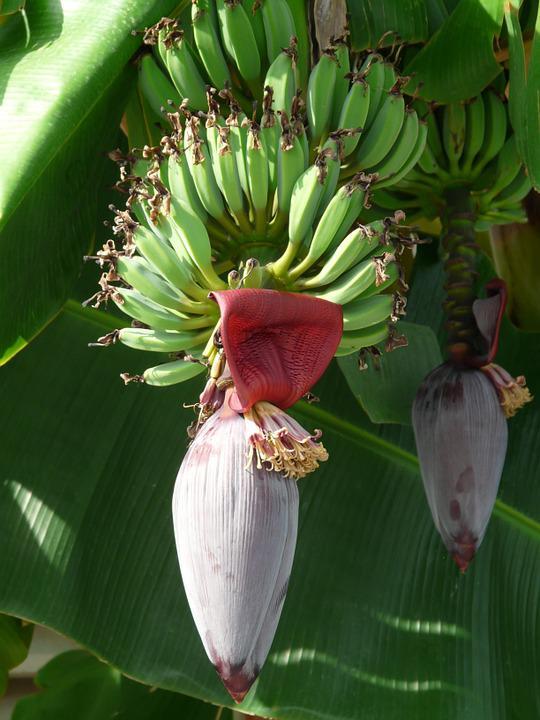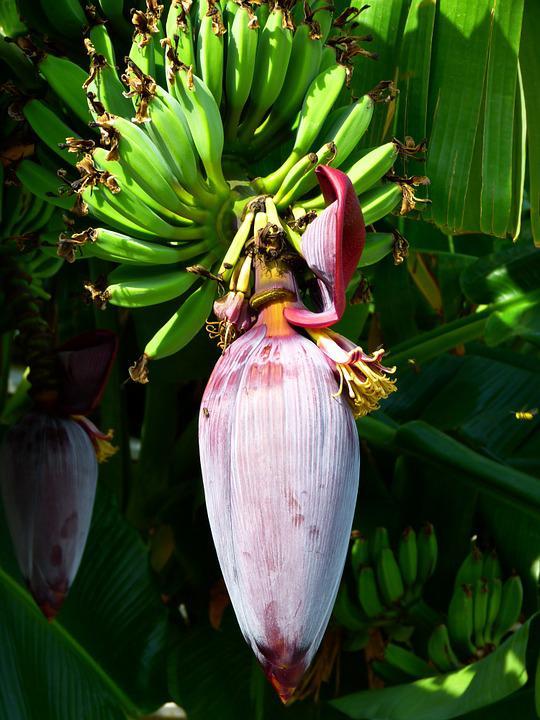The first image is the image on the left, the second image is the image on the right. For the images displayed, is the sentence "At the bottom of the bananas the flower has at least four petals open." factually correct? Answer yes or no. No. The first image is the image on the left, the second image is the image on the right. Evaluate the accuracy of this statement regarding the images: "There is exactly one flower petal in the left image.". Is it true? Answer yes or no. Yes. 